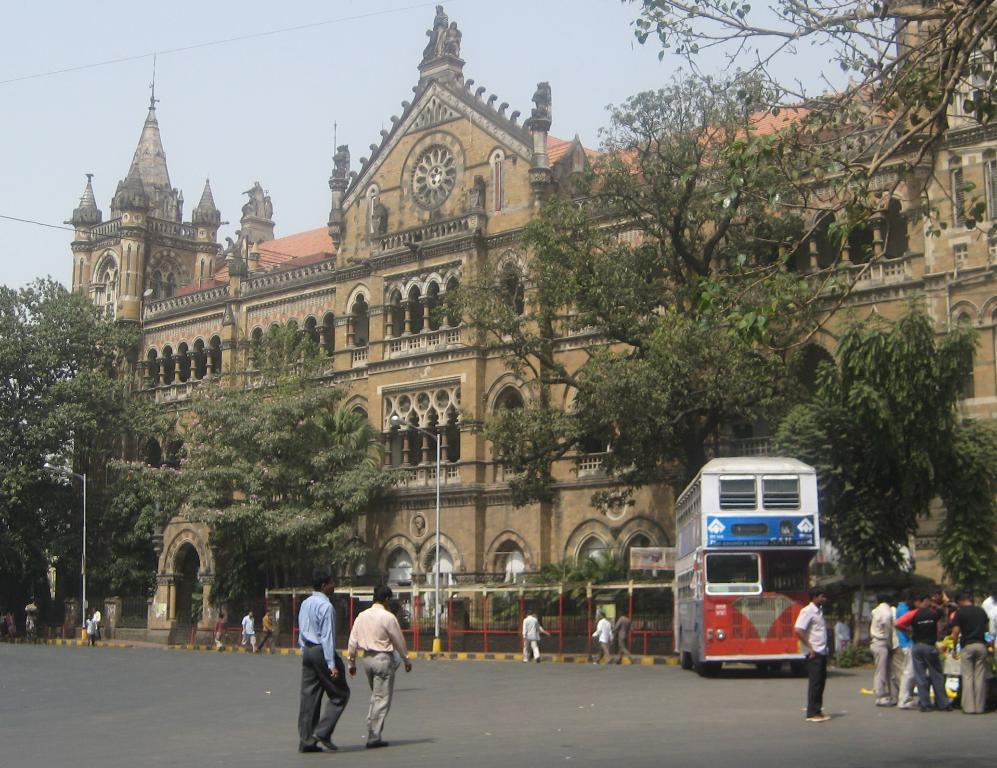What type of structures can be seen in the image? There are buildings in the image. What other natural elements are present in the image? There are trees in the image. What mode of transportation is visible in the image? There is a double-decker bus in the image. What are the vertical structures in the image used for? The poles in the image are likely used for supporting wires or signs. Can you describe the people in the image? There are people standing and walking in the image. How would you describe the weather in the image? The sky is cloudy in the image. What is the manager doing in the image? There is no mention of a manager in the image, so it is not possible to answer that question. How does the double-decker bus smash through the buildings in the image? The double-decker bus does not smash through the buildings in the image; it is stationary and not causing any damage. 